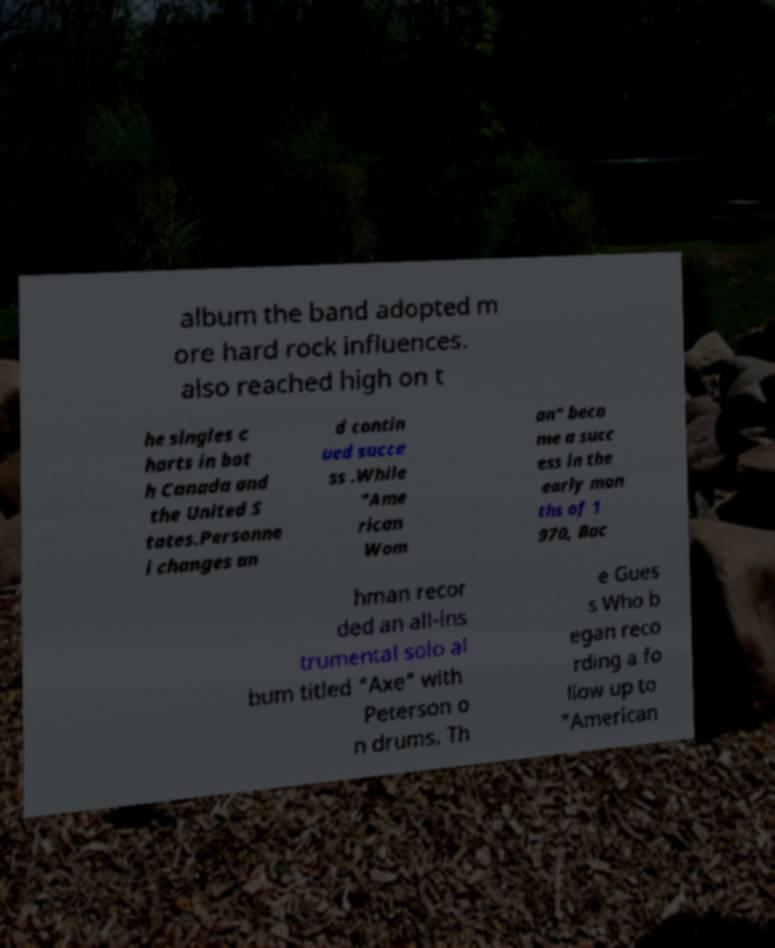What messages or text are displayed in this image? I need them in a readable, typed format. album the band adopted m ore hard rock influences. also reached high on t he singles c harts in bot h Canada and the United S tates.Personne l changes an d contin ued succe ss .While "Ame rican Wom an" beca me a succ ess in the early mon ths of 1 970, Bac hman recor ded an all-ins trumental solo al bum titled "Axe" with Peterson o n drums. Th e Gues s Who b egan reco rding a fo llow up to "American 